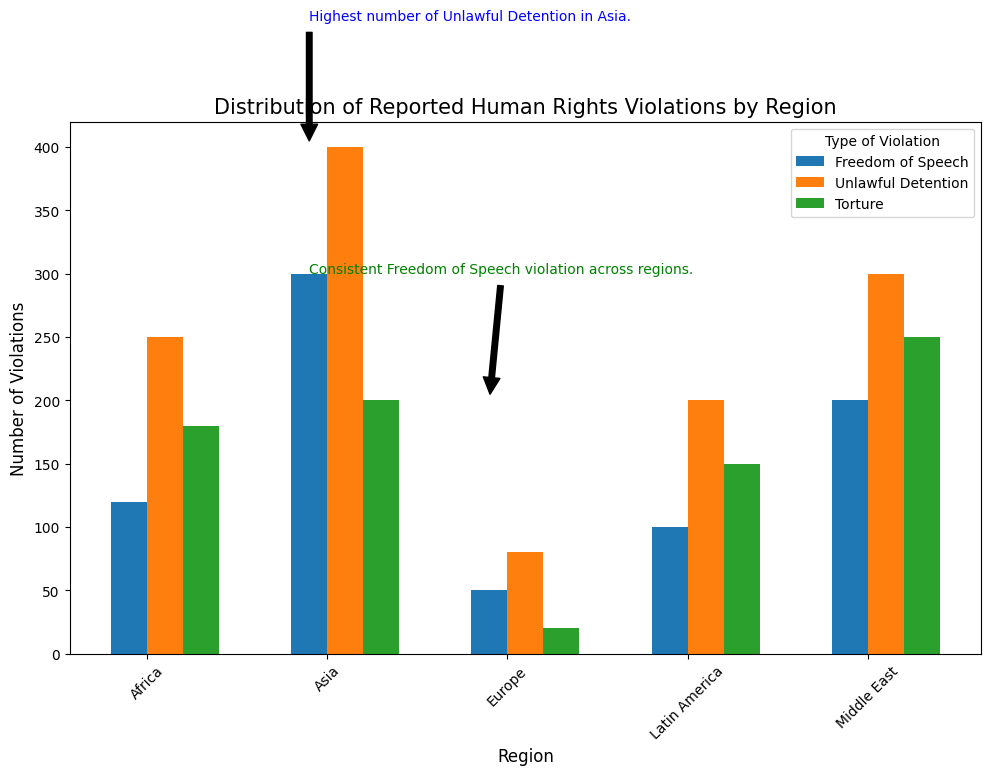What's the total number of reported violations in Africa? Add up the counts for each type of violation in Africa: (120 for Freedom of Speech) + (250 for Unlawful Detention) + (180 for Torture) = 550
Answer: 550 Which type of violation has the highest count in the Middle East? Compare the bars corresponding to each violation type within the Middle East: Freedom of Speech (200), Unlawful Detention (300), Torture (250). Unlawful Detention has the highest count of 300
Answer: Unlawful Detention Is the count for Torture in Europe greater than the count for Freedom of Speech in Latin America? Compare the bars: Torture in Europe is 20 and Freedom of Speech in Latin America is 100. Since 20 < 100, the count for Torture in Europe is not greater
Answer: No Which region has the smallest number of reported Unlawful Detention violations? Look at the bars for Unlawful Detention across regions: Africa (250), Asia (400), Europe (80), Latin America (200), Middle East (300). Europe has the smallest number, 80
Answer: Europe What's the average number of reported violations in Asia for all types of violations? Calculate the average by adding the counts and dividing by the number of violation types: (300 for Freedom of Speech) + (400 for Unlawful Detention) + (200 for Torture) = 900 total. There are 3 types of violations, so the average is 900 / 3 = 300
Answer: 300 Which annotation provides information about Unlawful Detention? Identify the annotation text related to Unlawful Detention: "Highest number of Unlawful Detention in Asia." This matches annotation 1
Answer: Annotation 1 Are there more Freedom of Speech violations in the Middle East than in Africa? Compare the counts for Freedom of Speech violations: Middle East (200) and Africa (120). Since 200 > 120, the Middle East has more
Answer: Yes How do the counts for Torture in Latin America compare with Torture in Africa? Compare the bars: Torture in Latin America (150) and Torture in Africa (180). Since 150 < 180, Asia has more
Answer: Latin America has fewer 